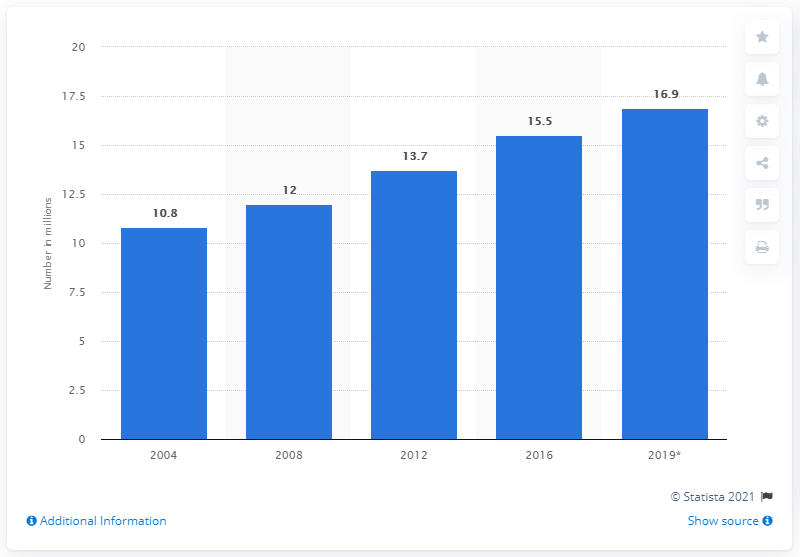Outline some significant characteristics in this image. In 2019, it was estimated that approximately 16.9% of individuals who had a history of cancer were still alive. Since 2004, the rate of living among U.S. Americans with a history of cancer has risen significantly. 